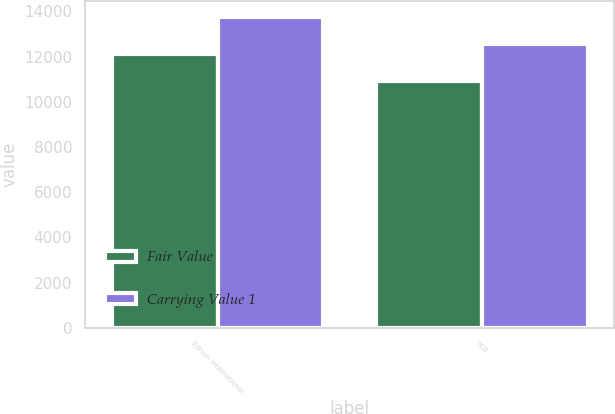Convert chart. <chart><loc_0><loc_0><loc_500><loc_500><stacked_bar_chart><ecel><fcel>Edison International<fcel>SCE<nl><fcel>Fair Value<fcel>12123<fcel>10907<nl><fcel>Carrying Value 1<fcel>13760<fcel>12547<nl></chart> 